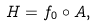Convert formula to latex. <formula><loc_0><loc_0><loc_500><loc_500>H = f _ { 0 } \circ A ,</formula> 